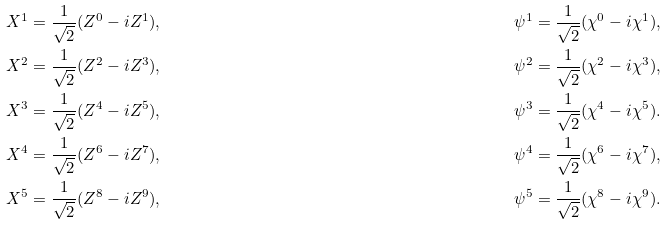Convert formula to latex. <formula><loc_0><loc_0><loc_500><loc_500>& X ^ { 1 } = \frac { 1 } { \sqrt { 2 } } ( Z ^ { 0 } - i Z ^ { 1 } ) , & & \psi ^ { 1 } = \frac { 1 } { \sqrt { 2 } } ( \chi ^ { 0 } - i \chi ^ { 1 } ) , \\ & X ^ { 2 } = \frac { 1 } { \sqrt { 2 } } ( Z ^ { 2 } - i Z ^ { 3 } ) , & & \psi ^ { 2 } = \frac { 1 } { \sqrt { 2 } } ( \chi ^ { 2 } - i \chi ^ { 3 } ) , \\ & X ^ { 3 } = \frac { 1 } { \sqrt { 2 } } ( Z ^ { 4 } - i Z ^ { 5 } ) , & & \psi ^ { 3 } = \frac { 1 } { \sqrt { 2 } } ( \chi ^ { 4 } - i \chi ^ { 5 } ) . \\ & X ^ { 4 } = \frac { 1 } { \sqrt { 2 } } ( Z ^ { 6 } - i Z ^ { 7 } ) , & & \psi ^ { 4 } = \frac { 1 } { \sqrt { 2 } } ( \chi ^ { 6 } - i \chi ^ { 7 } ) , \\ & X ^ { 5 } = \frac { 1 } { \sqrt { 2 } } ( Z ^ { 8 } - i Z ^ { 9 } ) , & & \psi ^ { 5 } = \frac { 1 } { \sqrt { 2 } } ( \chi ^ { 8 } - i \chi ^ { 9 } ) .</formula> 